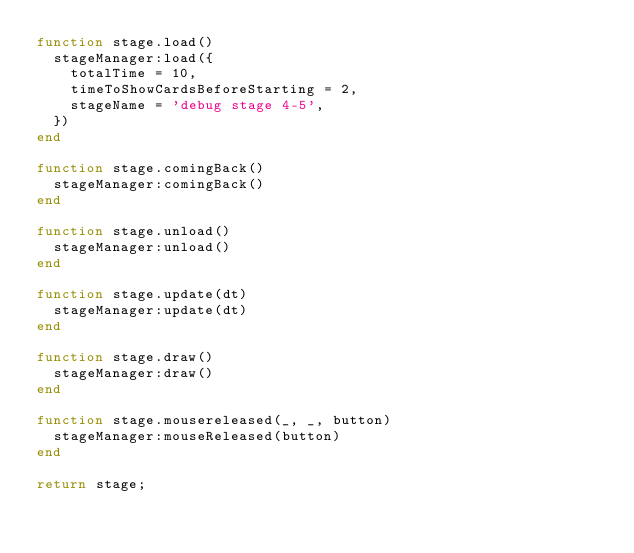<code> <loc_0><loc_0><loc_500><loc_500><_Lua_>function stage.load()
  stageManager:load({
    totalTime = 10,
    timeToShowCardsBeforeStarting = 2,
    stageName = 'debug stage 4-5',
  })
end

function stage.comingBack()
  stageManager:comingBack()
end

function stage.unload()
  stageManager:unload()
end

function stage.update(dt)
  stageManager:update(dt)
end

function stage.draw()
  stageManager:draw()
end

function stage.mousereleased(_, _, button)
  stageManager:mouseReleased(button)
end

return stage;
</code> 